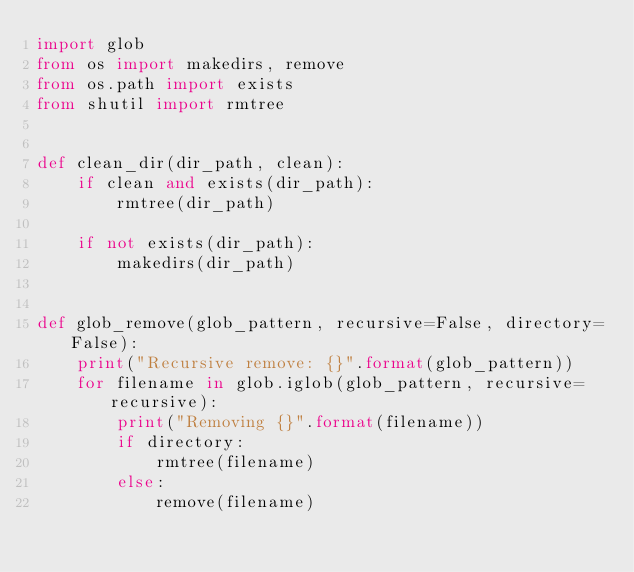Convert code to text. <code><loc_0><loc_0><loc_500><loc_500><_Python_>import glob
from os import makedirs, remove
from os.path import exists
from shutil import rmtree


def clean_dir(dir_path, clean):
    if clean and exists(dir_path):
        rmtree(dir_path)

    if not exists(dir_path):
        makedirs(dir_path)


def glob_remove(glob_pattern, recursive=False, directory=False):
    print("Recursive remove: {}".format(glob_pattern))
    for filename in glob.iglob(glob_pattern, recursive=recursive):
        print("Removing {}".format(filename))
        if directory:
            rmtree(filename)
        else:
            remove(filename)
</code> 